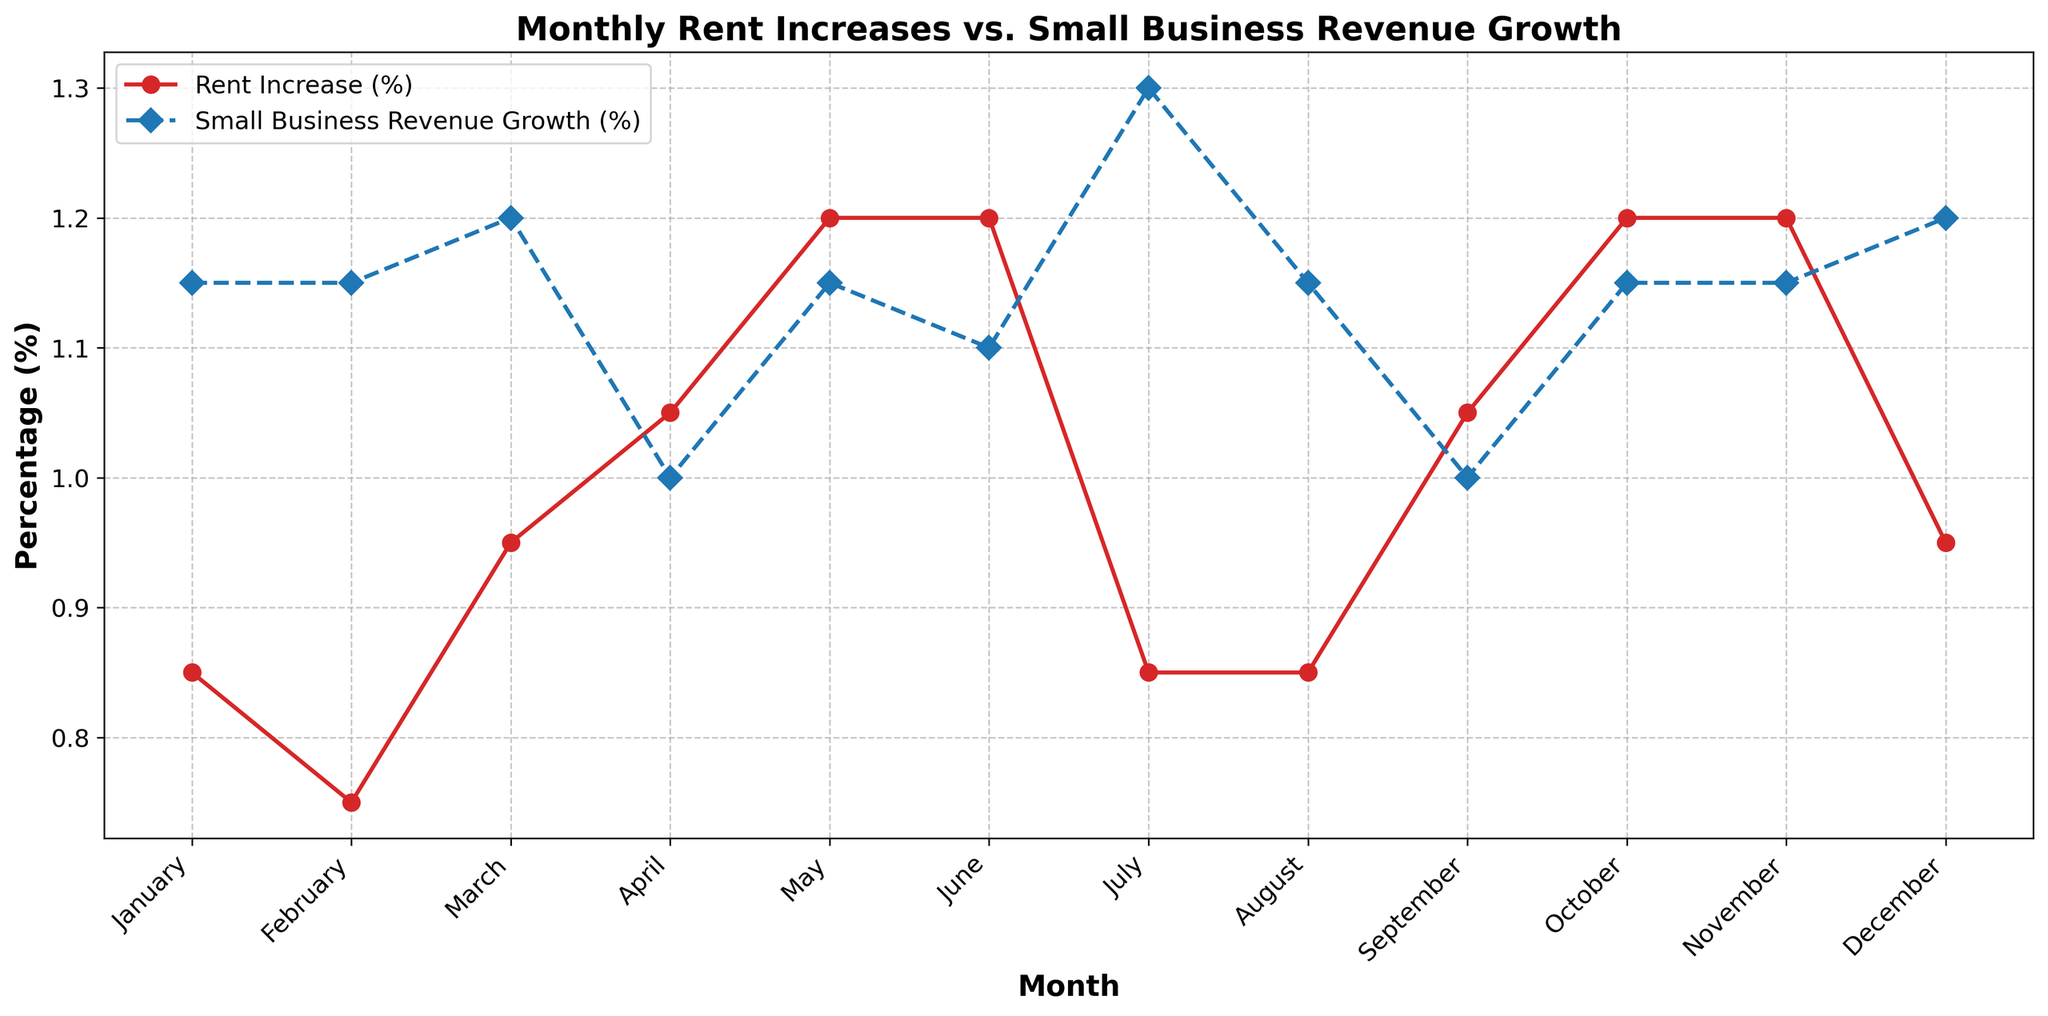Which month has the highest average rent increase? By evaluating the plot, we observe the highest peak of the line representing rent increases. This peak visibly occurs in June.
Answer: June How does the average rent increase in July compare to January? By looking at the red line representing rent increase data points for July and January, we see that July is at 0.85%, while January is at 0.85%, meaning they are the same.
Answer: They are the same Which month shows an equal percentage for both rent increase and business revenue growth? By inspecting both lines for their intersections or overlapping points, April, September, and October show equal values for rent increase and revenue growth, both around 1%.
Answer: April, September, October What is the average rent increase percentage across all months? We notice that every month's rent increase is plotted. Summing these values (0.8+0.7+0.9+1.0+1.2+1.1+0.7+0.8+1.0+1.2+1.1+0.9+0.9+0.8+1.0+1.1+1.2+1.3+1.0+0.9+1.1+1.2+1.3+1.0) and then dividing by 24 (number of months) gives: 24.4/24.
Answer: 1.02% What's the largest difference between rent increase and small business revenue growth in a single month? We must check all months to see maximum absolute differences. January (0.9, 1.2) has the largest difference, which equals 0.3%.
Answer: 0.3% in June Is small business revenue growth higher in March or May? Looking at the blue line for March (1.3%) and May (1.2%), March has a slightly higher percentage.
Answer: March In which months does the rent increase exceed revenue growth the most? We focus on the points where the red line is significantly above the blue one. This happens in June and November, where rent significantly exceeds revenue growth.
Answer: June, November Is the rent increase constant or does it show variations across months? By examining the red line, we see variances with some peaks and troughs, indicating that rent increases vary month to month.
Answer: Shows variations 